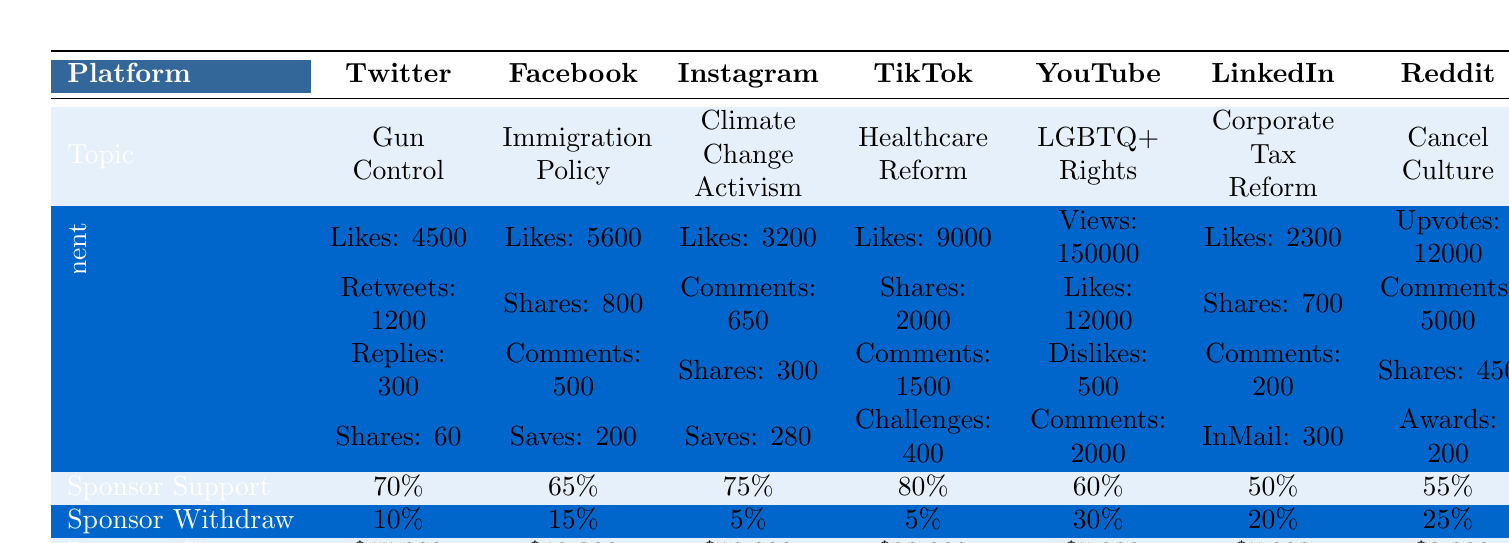What controversial topic received the most likes on Twitter? Referring to the table under the Twitter column, the topic "Gun Control" received 4500 likes, which is the only entry for Twitter.
Answer: Gun Control Which platform had the highest revenue change for controversial discussions? By inspecting the revenue change row, TikTok shows a revenue change of $20,000, which is the highest among all platforms listed.
Answer: $20,000 How many sponsors withdrew for discussions about LGBTQ+ Rights? Looking at the sponsorship impact for YouTube, there is a 30% sponsor withdrawal noted for the topic of LGBTQ+ Rights.
Answer: 30% What is the average sponsor support across all platforms? Adding the sponsor support percentages (70, 65, 75, 80, 60, 50, 55) gives 435. Dividing by 7 (the number of platforms) results in an average of approximately 62.14%.
Answer: 62.14% Did TikTok have a lower sponsor withdrawal rate than YouTube? TikTok has a sponsor withdrawal rate of 5%, while YouTube has a 30% withdrawal rate. 5% is less than 30%, confirming that TikTok did have a lower rate.
Answer: Yes Which platform had the least number of likes recorded for controversial topics? Comparing the like counts across all platforms, Instagram had the least with 3200 likes, as it's lower than all other platforms listed.
Answer: 3200 If we focus on sponsor support rates, which platform had exactly 55%? Referring to the sponsor support row, Reddit shows a sponsor support rate of 55%, which is explicitly noted.
Answer: Reddit Which controversial topic on Facebook had the most shares? Examining the Facebook row, "Immigration Policy" resulted in 800 shares, the only entry in this category for Facebook.
Answer: Immigration Policy Calculate the total number of likes across all platforms discussed. Summing the likes: 4500 (Twitter) + 5600 (Facebook) + 3200 (Instagram) + 9000 (TikTok) + 12000 (YouTube) + 2300 (LinkedIn) + 12000 (Reddit) totals to 47700 likes.
Answer: 47700 Was the topic of Healthcare Reform more positively impactful in terms of revenue change than Corporate Tax Reform? Healthcare Reform on TikTok shows a positive revenue change of $20,000, while Corporate Tax Reform on LinkedIn shows a positive change of $5,000. Comparing them, $20,000 is greater than $5,000, indicating a more positive impact.
Answer: Yes 